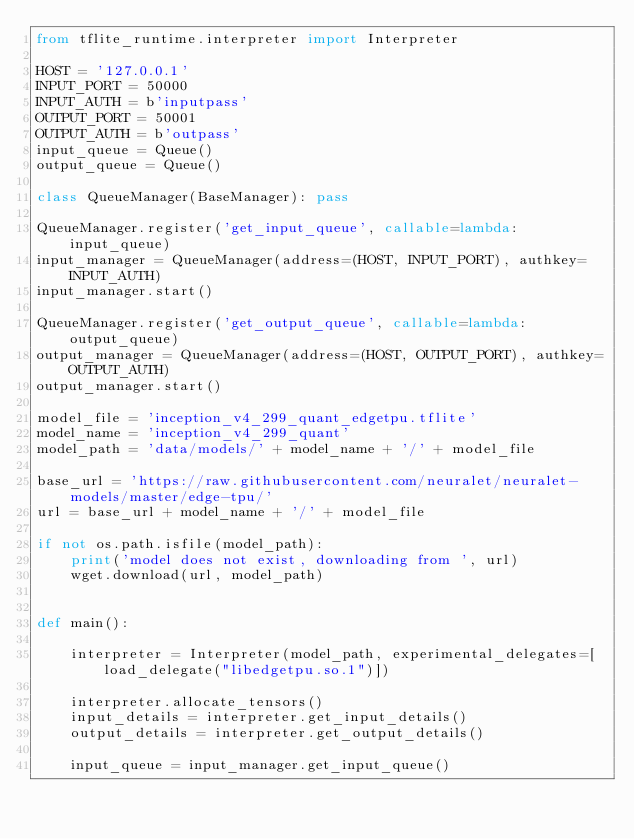Convert code to text. <code><loc_0><loc_0><loc_500><loc_500><_Python_>from tflite_runtime.interpreter import Interpreter

HOST = '127.0.0.1'
INPUT_PORT = 50000
INPUT_AUTH = b'inputpass'
OUTPUT_PORT = 50001
OUTPUT_AUTH = b'outpass'
input_queue = Queue()
output_queue = Queue()

class QueueManager(BaseManager): pass

QueueManager.register('get_input_queue', callable=lambda:input_queue)
input_manager = QueueManager(address=(HOST, INPUT_PORT), authkey=INPUT_AUTH)
input_manager.start()

QueueManager.register('get_output_queue', callable=lambda:output_queue)
output_manager = QueueManager(address=(HOST, OUTPUT_PORT), authkey=OUTPUT_AUTH)
output_manager.start()

model_file = 'inception_v4_299_quant_edgetpu.tflite'
model_name = 'inception_v4_299_quant'
model_path = 'data/models/' + model_name + '/' + model_file

base_url = 'https://raw.githubusercontent.com/neuralet/neuralet-models/master/edge-tpu/'
url = base_url + model_name + '/' + model_file

if not os.path.isfile(model_path):
    print('model does not exist, downloading from ', url)
    wget.download(url, model_path)


def main():

    interpreter = Interpreter(model_path, experimental_delegates=[load_delegate("libedgetpu.so.1")])

    interpreter.allocate_tensors()
    input_details = interpreter.get_input_details()
    output_details = interpreter.get_output_details()

    input_queue = input_manager.get_input_queue()</code> 